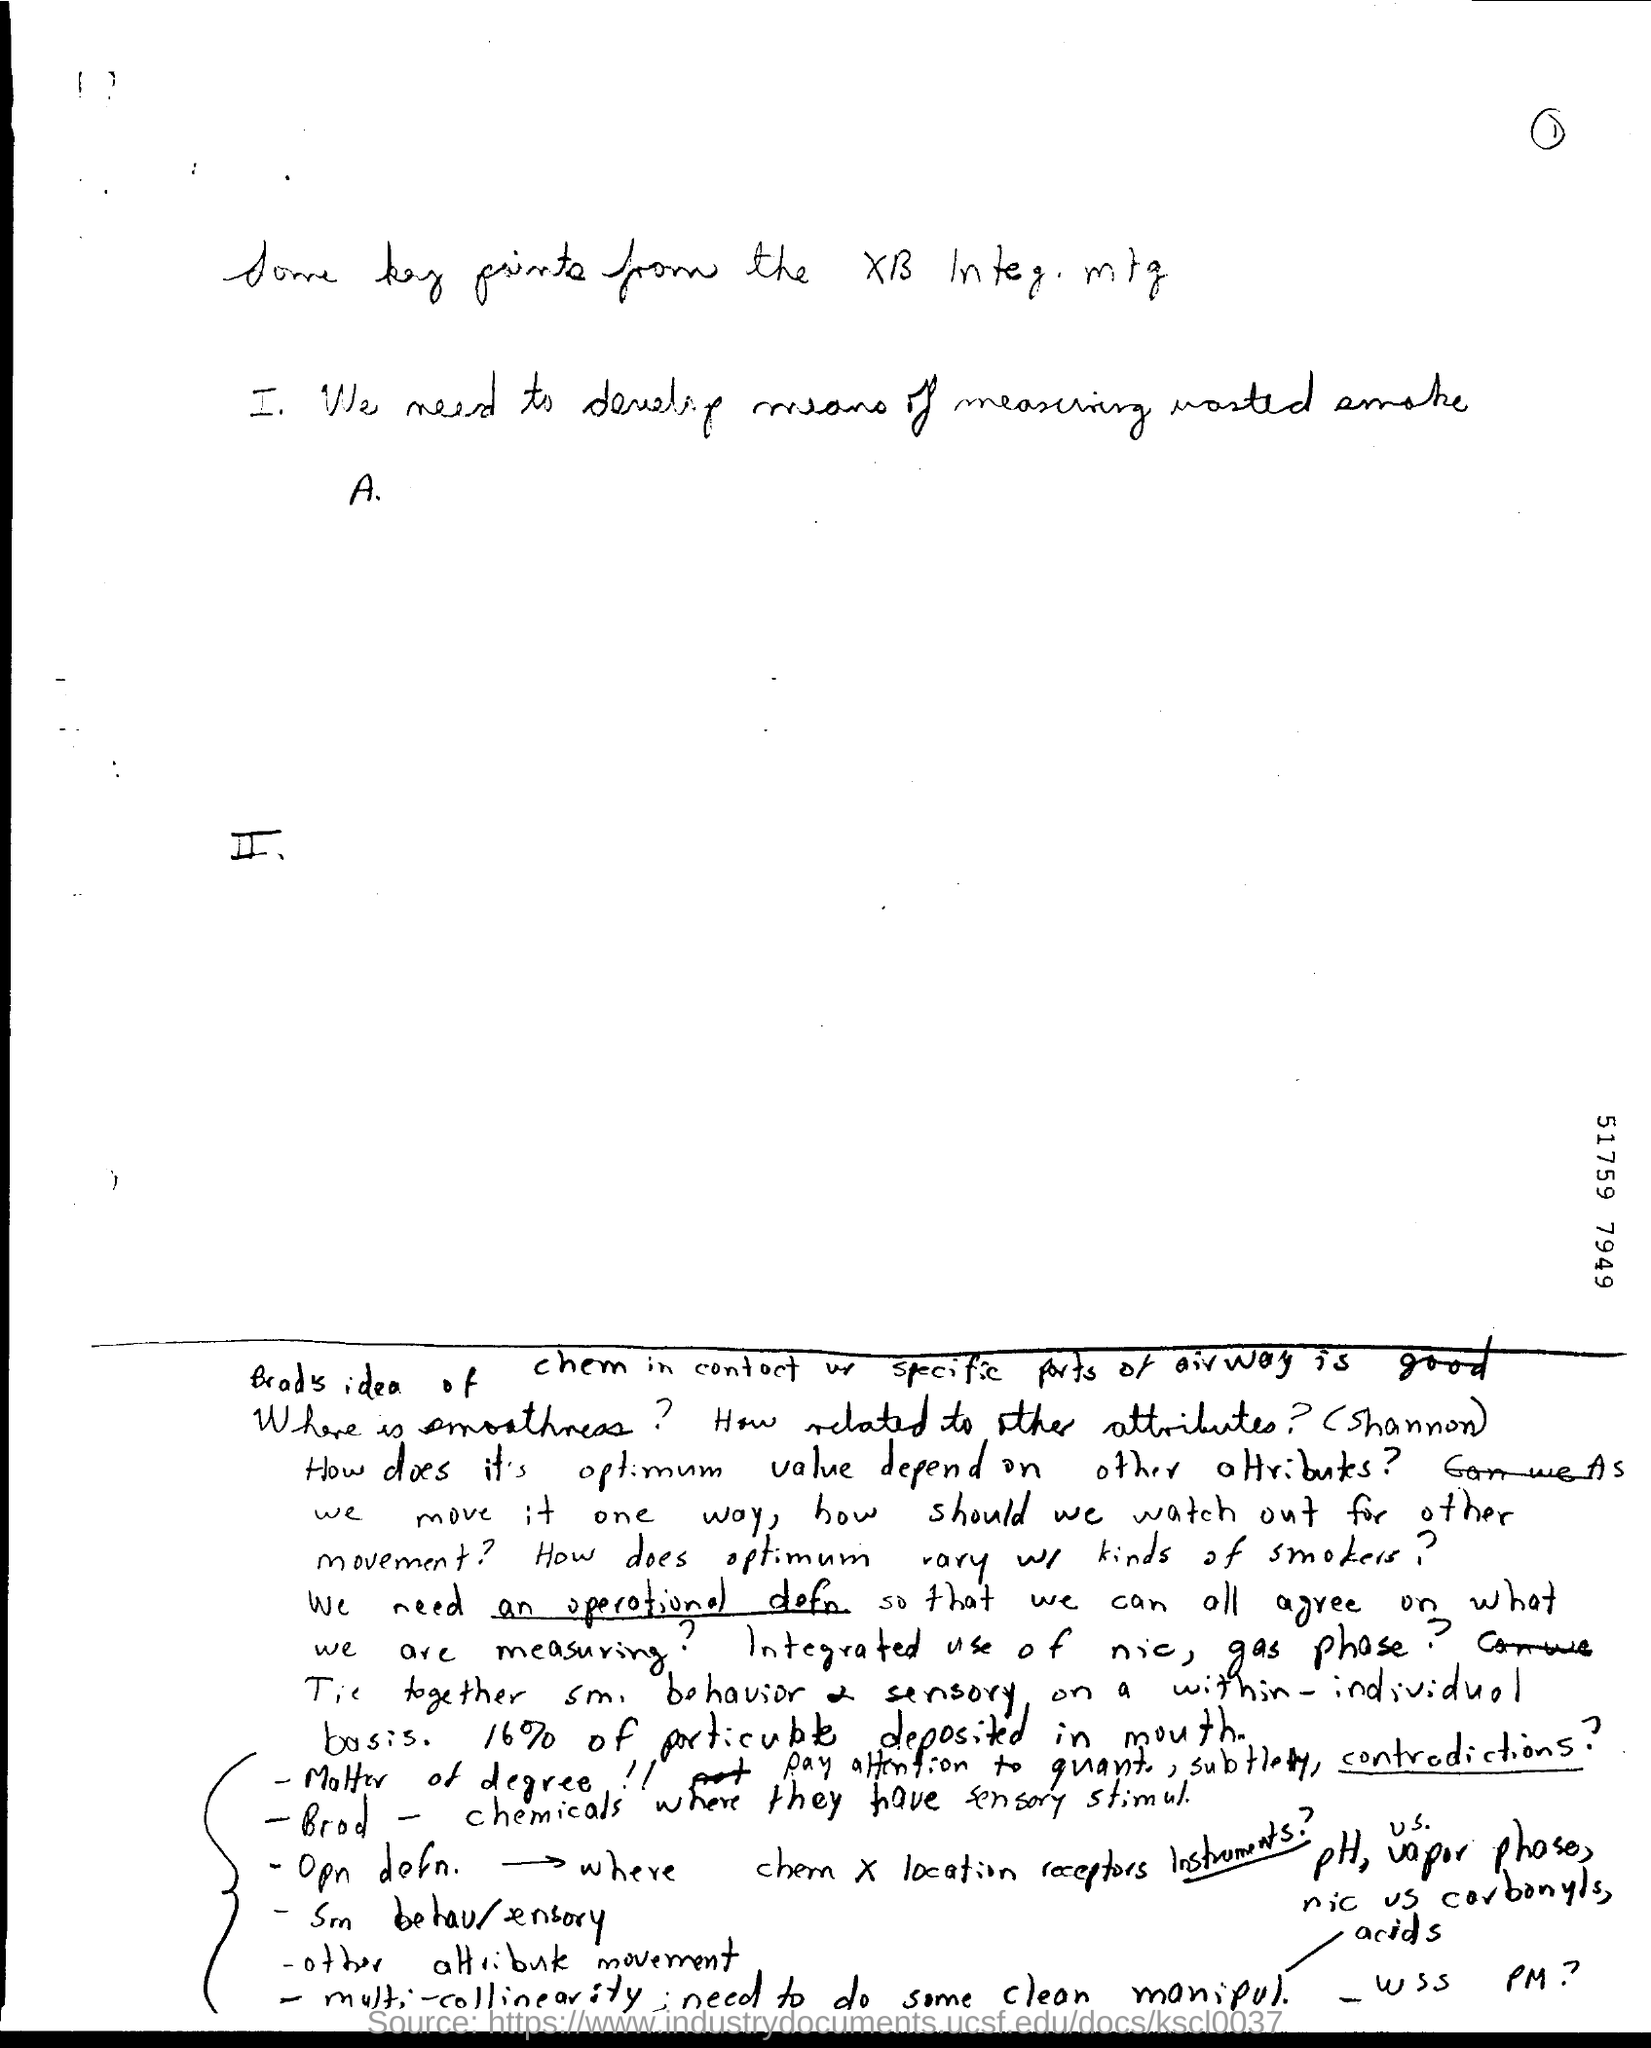What is the number specified on the right side of the doument?
Make the answer very short. 51759 7949. What is the page no mentioned in this document?
Give a very brief answer. 1. 